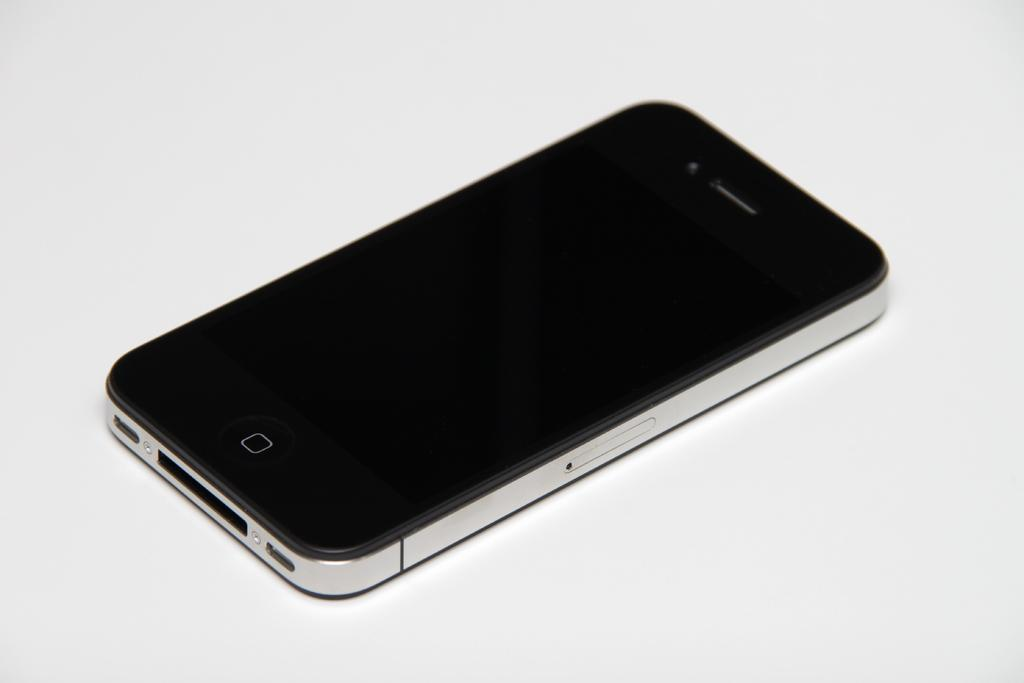What is the main subject of the image? The main subject of the image is a mobile. Can you describe the placement of the mobile in the image? The mobile is placed on an object. What type of bread is being offered in the image? There is no bread present in the image; it only features a mobile placed on an object. 